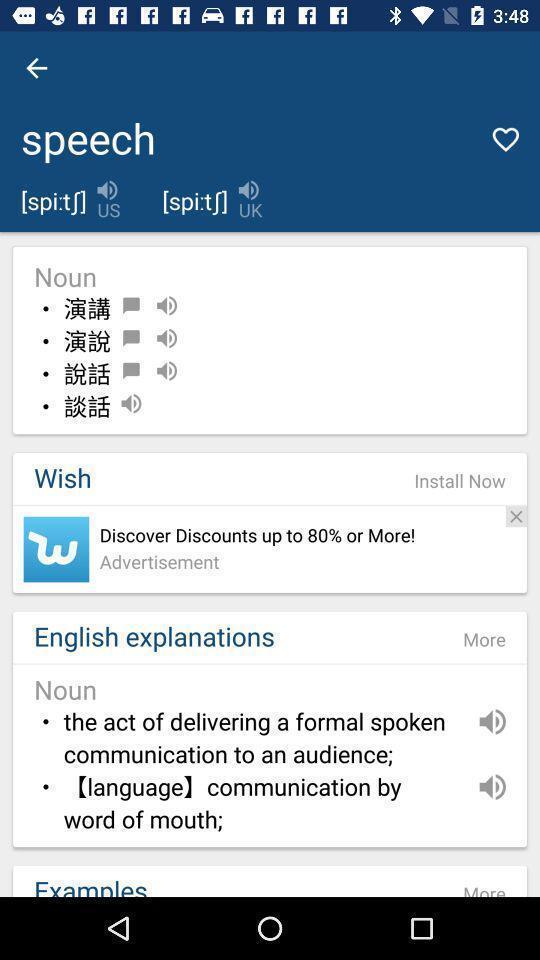Describe the visual elements of this screenshot. Page shows the speech translation and meaning on language app. 